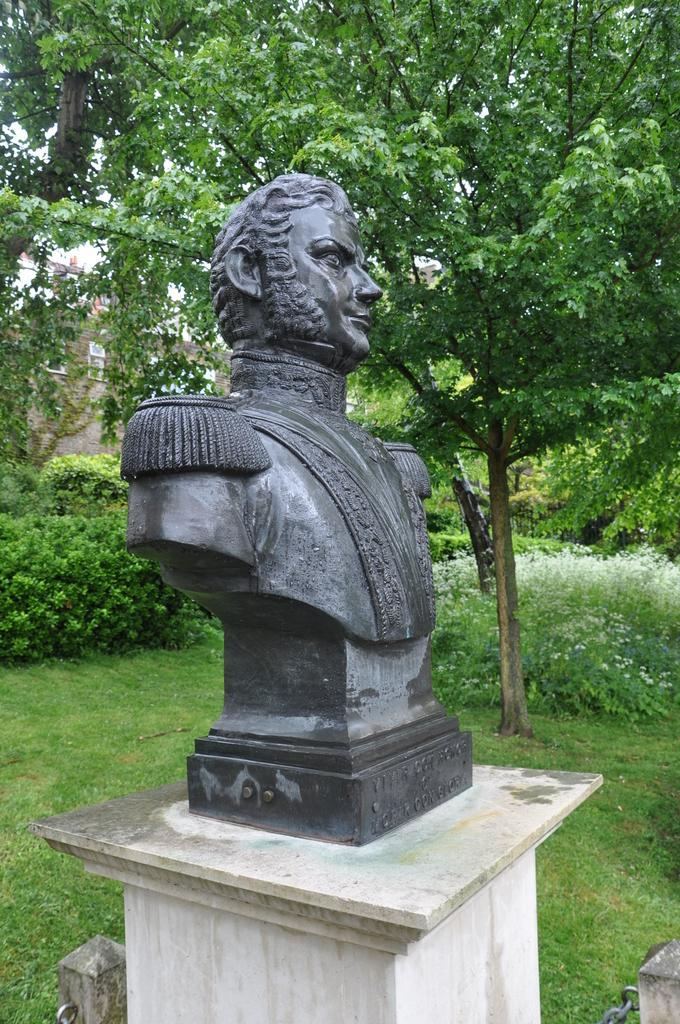What is the main subject of the image? There is a carved statue in the image. What is the statue standing on? The statue has a base. What type of natural environment is visible in the image? There is grass on the ground, plants, and trees in the image. What type of punishment is being carried out on the statue in the image? There is no punishment being carried out on the statue in the image; it is a stationary object. What type of wilderness can be seen in the image? The image does not depict a wilderness setting; it features a carved statue surrounded by grass, plants, and trees. 